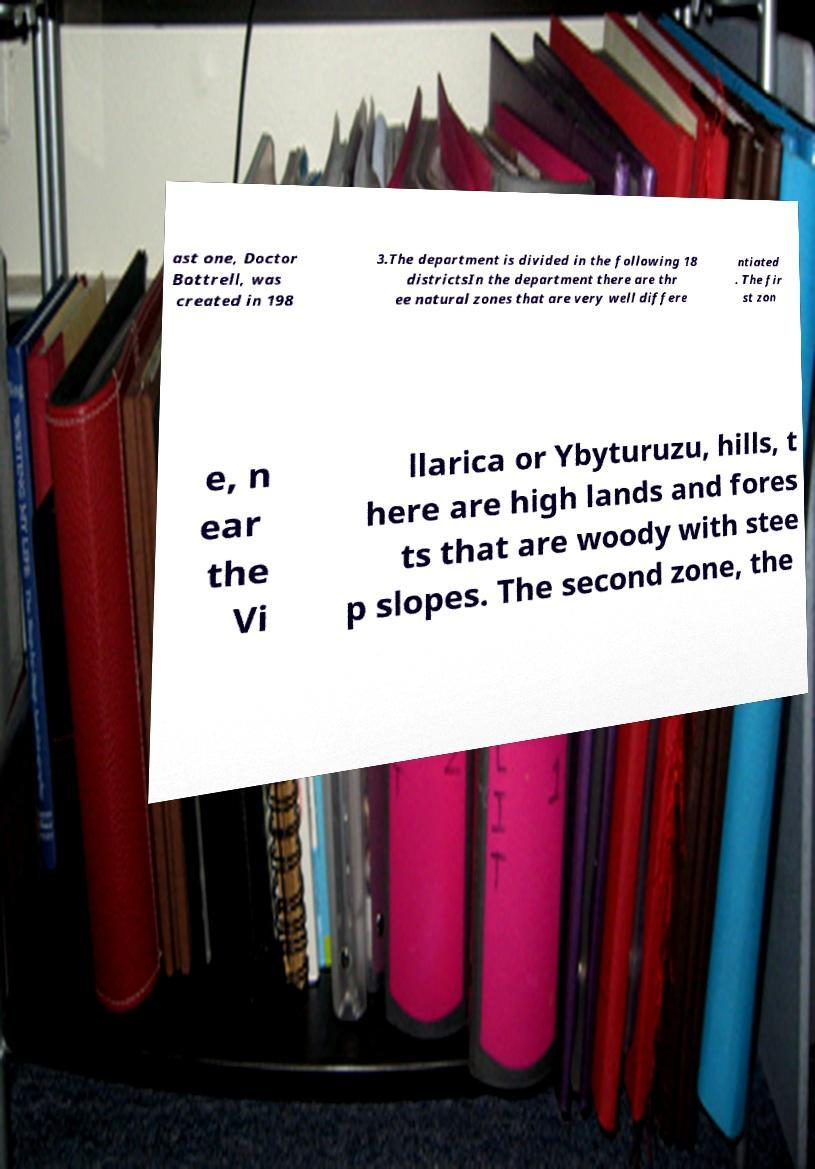Could you extract and type out the text from this image? ast one, Doctor Bottrell, was created in 198 3.The department is divided in the following 18 districtsIn the department there are thr ee natural zones that are very well differe ntiated . The fir st zon e, n ear the Vi llarica or Ybyturuzu, hills, t here are high lands and fores ts that are woody with stee p slopes. The second zone, the 